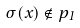<formula> <loc_0><loc_0><loc_500><loc_500>\sigma ( x ) \notin p _ { 1 }</formula> 